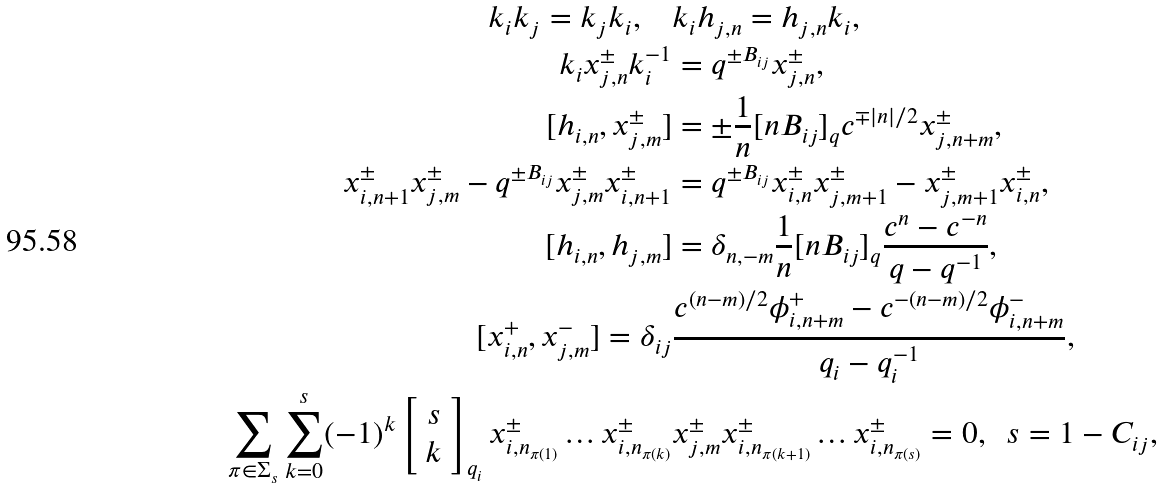Convert formula to latex. <formula><loc_0><loc_0><loc_500><loc_500>k _ { i } k _ { j } = k _ { j } k _ { i } , \quad & k _ { i } h _ { j , n } = h _ { j , n } k _ { i } , \\ k _ { i } x ^ { \pm } _ { j , n } k _ { i } ^ { - 1 } & = q ^ { \pm B _ { i j } } x _ { j , n } ^ { \pm } , \\ [ h _ { i , n } , x _ { j , m } ^ { \pm } ] & = \pm \frac { 1 } { n } [ n B _ { i j } ] _ { q } c ^ { \mp { | n | / 2 } } x _ { j , n + m } ^ { \pm } , \\ x _ { i , n + 1 } ^ { \pm } x _ { j , m } ^ { \pm } - q ^ { \pm B _ { i j } } x _ { j , m } ^ { \pm } x _ { i , n + 1 } ^ { \pm } & = q ^ { \pm B _ { i j } } x _ { i , n } ^ { \pm } x _ { j , m + 1 } ^ { \pm } - x _ { j , m + 1 } ^ { \pm } x _ { i , n } ^ { \pm } , \\ [ h _ { i , n } , h _ { j , m } ] & = \delta _ { n , - m } \frac { 1 } { n } [ n B _ { i j } ] _ { q } \frac { c ^ { n } - c ^ { - n } } { q - q ^ { - 1 } } , \\ [ x _ { i , n } ^ { + } , x _ { j , m } ^ { - } ] = \delta _ { i j } & \frac { c ^ { ( n - m ) / 2 } \phi _ { i , n + m } ^ { + } - c ^ { - ( n - m ) / 2 } \phi _ { i , n + m } ^ { - } } { q _ { i } - q _ { i } ^ { - 1 } } , \\ \sum _ { \pi \in \Sigma _ { s } } \sum _ { k = 0 } ^ { s } ( - 1 ) ^ { k } \left [ \begin{array} { c c } s \\ k \end{array} \right ] _ { q _ { i } } x _ { i , n _ { \pi ( 1 ) } } ^ { \pm } \dots x _ { i , n _ { \pi ( k ) } } ^ { \pm } & x _ { j , m } ^ { \pm } x _ { i , n _ { \pi ( k + 1 ) } } ^ { \pm } \dots x _ { i , n _ { \pi ( s ) } } ^ { \pm } = 0 , \ \ s = 1 - C _ { i j } ,</formula> 